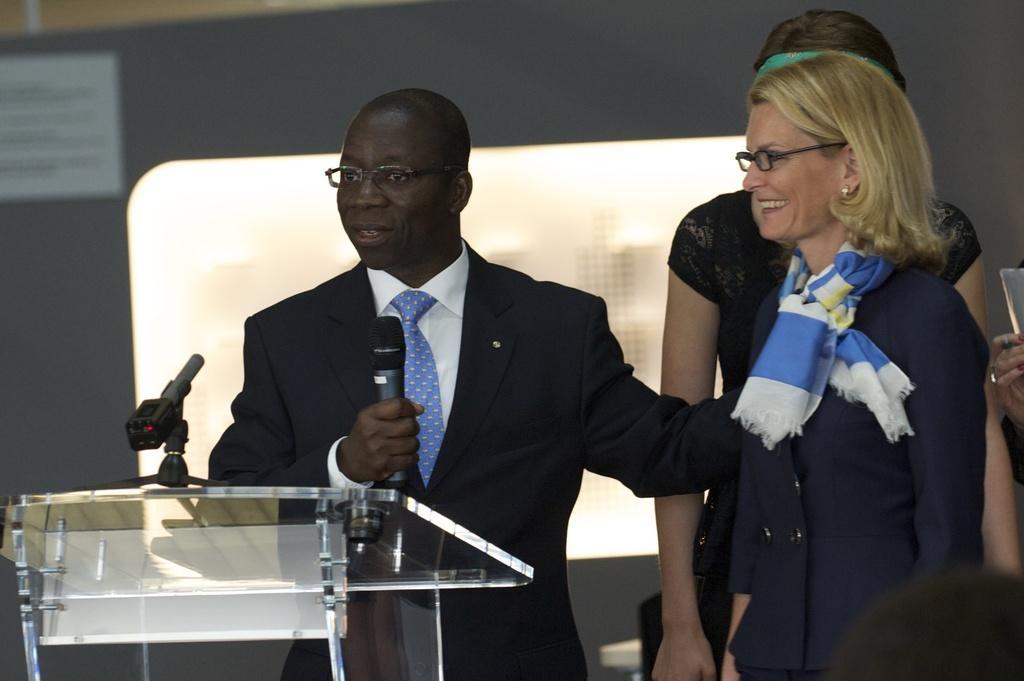How would you summarize this image in a sentence or two? In the image there is a man he is speaking something and beside him there are two women, he is holding a mic in his hand and there is a table in front of him. The background of the man is blur. 